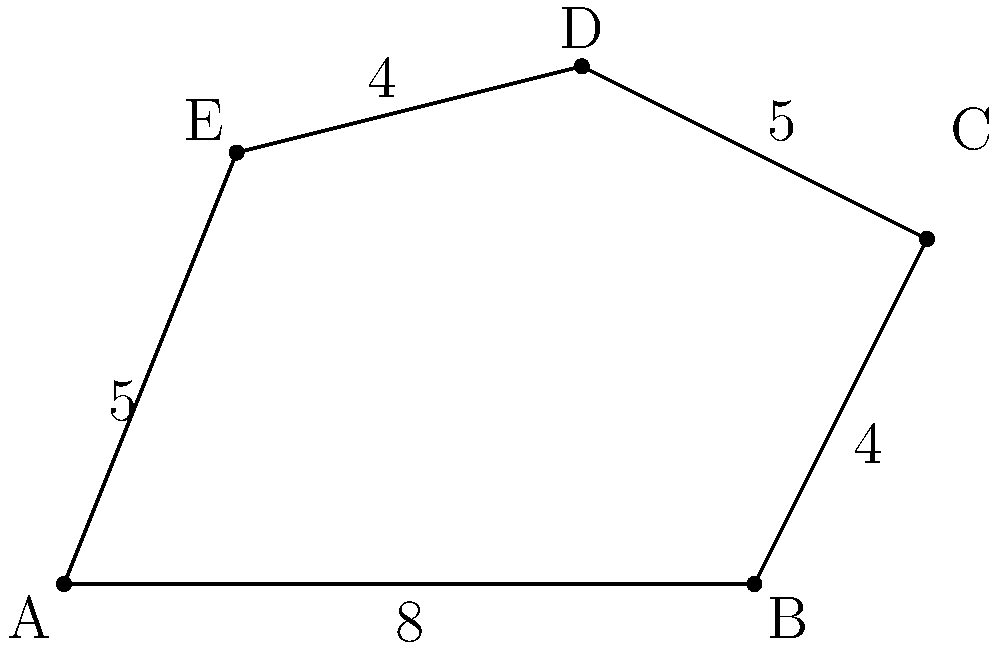As you reminisce about your performances in the Hill District, you recall a uniquely shaped stage at one of the jazz clubs. The stage was an irregular pentagon, as shown in the diagram. If the dimensions are in meters, what was the total area of this stage in square meters? Let's approach this step-by-step:

1) We can divide the irregular pentagon into three triangles: ABC, ACD, and ADE.

2) For triangle ABC:
   Base = 8 m, Height = 4 m
   Area of ABC = $\frac{1}{2} \times 8 \times 4 = 16$ sq m

3) For triangle ACD:
   We need to find its base and height.
   Base (AC) can be found using the Pythagorean theorem:
   $AC = \sqrt{8^2 + 4^2} = \sqrt{80} = 4\sqrt{5}$ m
   Height (perpendicular from D to AC) = 6 - 4 = 2 m
   Area of ACD = $\frac{1}{2} \times 4\sqrt{5} \times 2 = 4\sqrt{5}$ sq m

4) For triangle ADE:
   Base = 5 m, Height = 5 m
   Area of ADE = $\frac{1}{2} \times 5 \times 5 = 12.5$ sq m

5) Total area = Area of ABC + Area of ACD + Area of ADE
               = $16 + 4\sqrt{5} + 12.5$
               = $28.5 + 4\sqrt{5}$ sq m

6) Simplifying: $28.5 + 4\sqrt{5} \approx 37.44$ sq m
Answer: $28.5 + 4\sqrt{5}$ sq m (or approximately 37.44 sq m) 